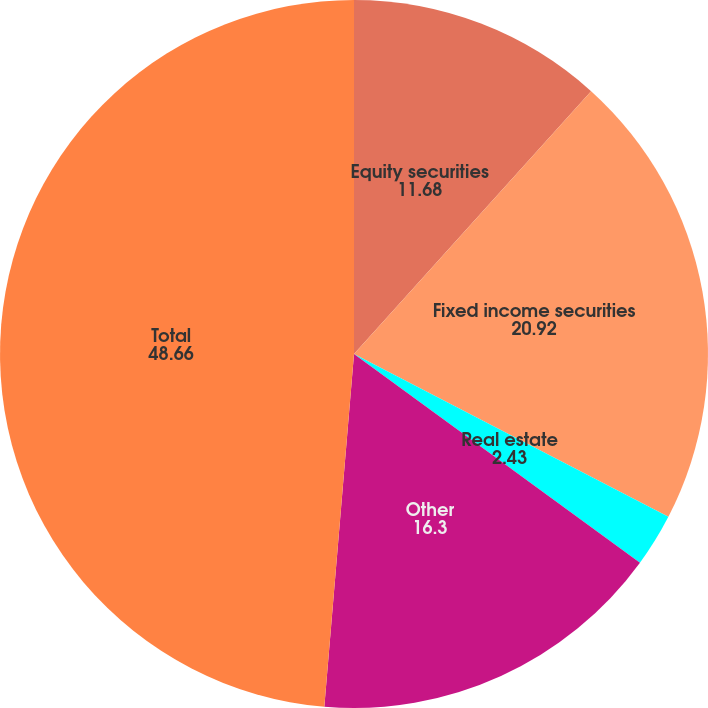<chart> <loc_0><loc_0><loc_500><loc_500><pie_chart><fcel>Equity securities<fcel>Fixed income securities<fcel>Real estate<fcel>Other<fcel>Total<nl><fcel>11.68%<fcel>20.92%<fcel>2.43%<fcel>16.3%<fcel>48.66%<nl></chart> 